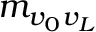Convert formula to latex. <formula><loc_0><loc_0><loc_500><loc_500>m _ { v _ { 0 } v _ { L } }</formula> 